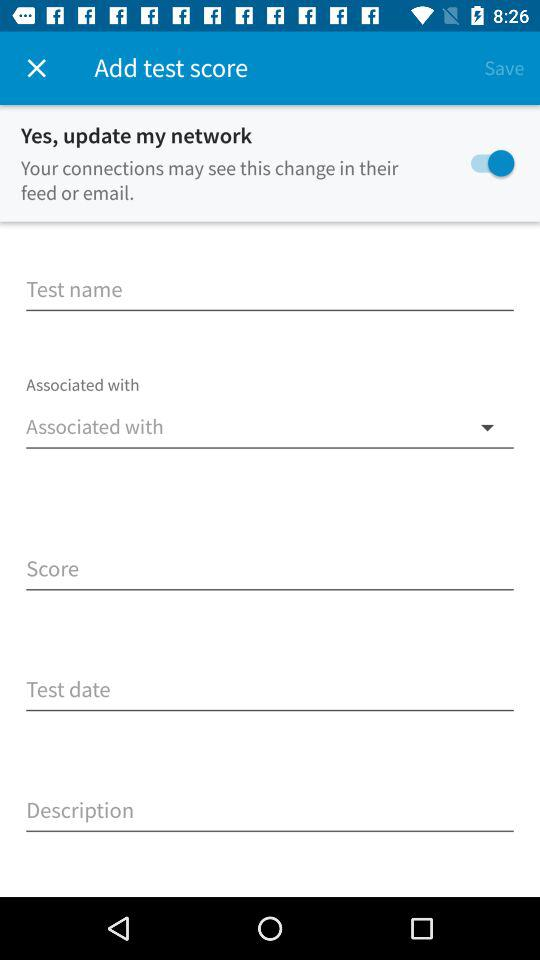What is the status of "Yes, update my network"? The status is "on". 